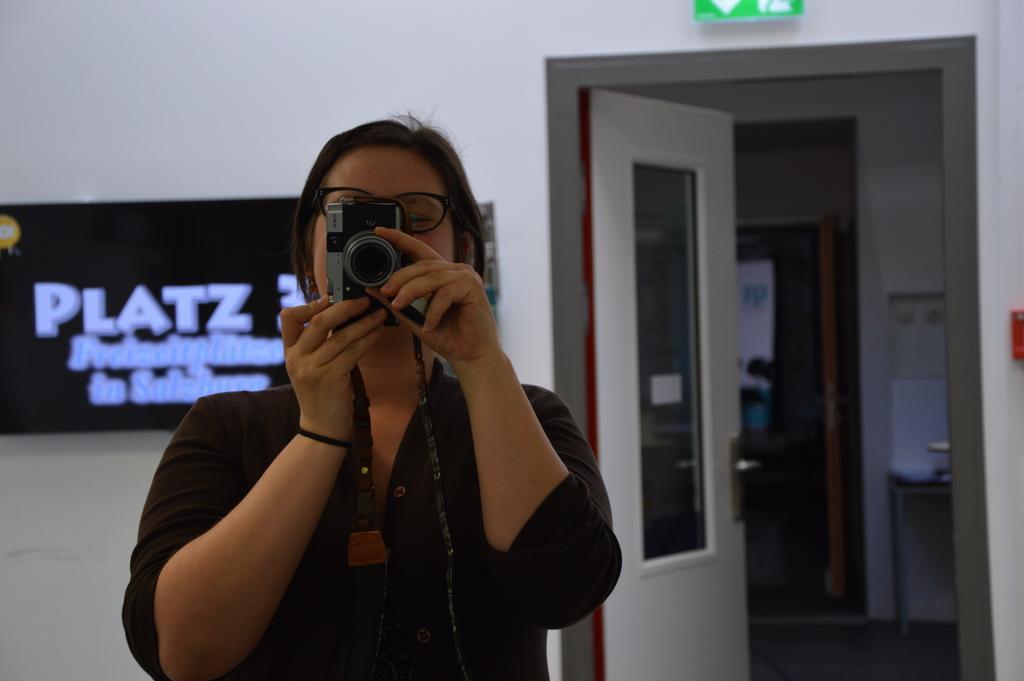In one or two sentences, can you explain what this image depicts? In this photograph there is a woman who is holding camera and capturing something she is wearing spectacles ,behind her there is a display board , behind the board there is a wall , beside the wall there is a room , inside the room there is another room, beside that there is a white color wall. 